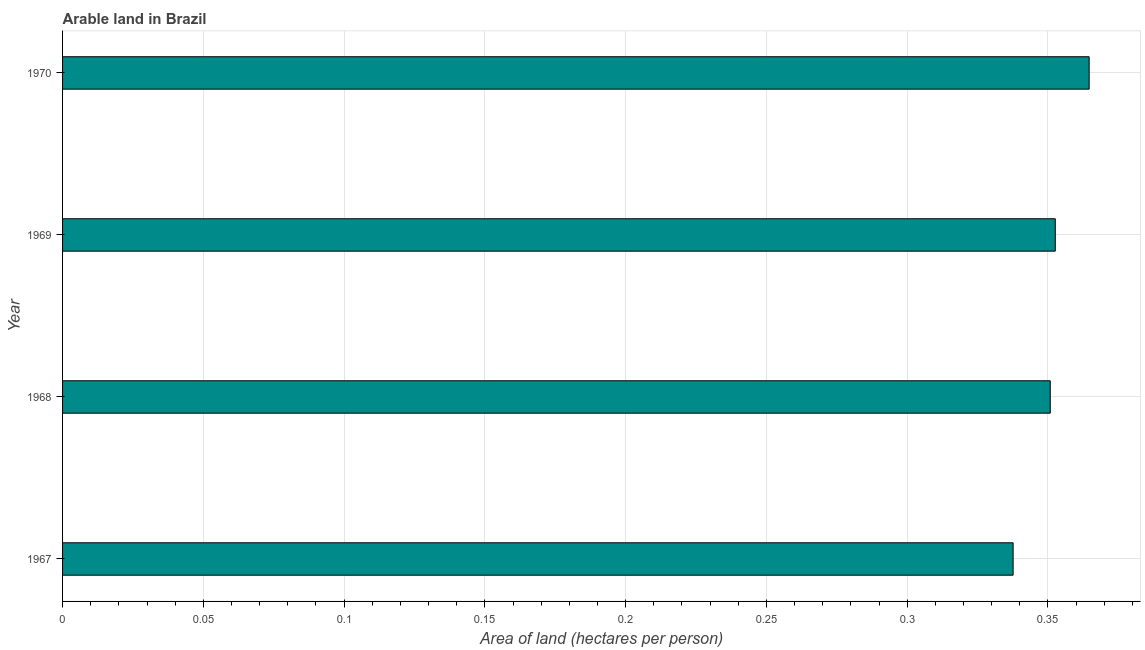Does the graph contain grids?
Your answer should be compact. Yes. What is the title of the graph?
Give a very brief answer. Arable land in Brazil. What is the label or title of the X-axis?
Your answer should be compact. Area of land (hectares per person). What is the label or title of the Y-axis?
Offer a terse response. Year. What is the area of arable land in 1970?
Provide a short and direct response. 0.36. Across all years, what is the maximum area of arable land?
Ensure brevity in your answer.  0.36. Across all years, what is the minimum area of arable land?
Make the answer very short. 0.34. In which year was the area of arable land maximum?
Your answer should be very brief. 1970. In which year was the area of arable land minimum?
Offer a terse response. 1967. What is the sum of the area of arable land?
Offer a very short reply. 1.41. What is the difference between the area of arable land in 1967 and 1968?
Give a very brief answer. -0.01. What is the average area of arable land per year?
Give a very brief answer. 0.35. What is the median area of arable land?
Offer a very short reply. 0.35. In how many years, is the area of arable land greater than 0.14 hectares per person?
Offer a very short reply. 4. What is the ratio of the area of arable land in 1967 to that in 1969?
Ensure brevity in your answer.  0.96. Is the difference between the area of arable land in 1967 and 1969 greater than the difference between any two years?
Ensure brevity in your answer.  No. What is the difference between the highest and the second highest area of arable land?
Provide a succinct answer. 0.01. Is the sum of the area of arable land in 1968 and 1969 greater than the maximum area of arable land across all years?
Provide a short and direct response. Yes. How many years are there in the graph?
Ensure brevity in your answer.  4. What is the difference between two consecutive major ticks on the X-axis?
Your answer should be compact. 0.05. What is the Area of land (hectares per person) of 1967?
Your answer should be compact. 0.34. What is the Area of land (hectares per person) in 1968?
Ensure brevity in your answer.  0.35. What is the Area of land (hectares per person) in 1969?
Your response must be concise. 0.35. What is the Area of land (hectares per person) of 1970?
Your response must be concise. 0.36. What is the difference between the Area of land (hectares per person) in 1967 and 1968?
Provide a succinct answer. -0.01. What is the difference between the Area of land (hectares per person) in 1967 and 1969?
Give a very brief answer. -0.01. What is the difference between the Area of land (hectares per person) in 1967 and 1970?
Your answer should be very brief. -0.03. What is the difference between the Area of land (hectares per person) in 1968 and 1969?
Offer a very short reply. -0. What is the difference between the Area of land (hectares per person) in 1968 and 1970?
Give a very brief answer. -0.01. What is the difference between the Area of land (hectares per person) in 1969 and 1970?
Make the answer very short. -0.01. What is the ratio of the Area of land (hectares per person) in 1967 to that in 1969?
Offer a very short reply. 0.96. What is the ratio of the Area of land (hectares per person) in 1967 to that in 1970?
Your response must be concise. 0.93. What is the ratio of the Area of land (hectares per person) in 1968 to that in 1969?
Give a very brief answer. 0.99. What is the ratio of the Area of land (hectares per person) in 1969 to that in 1970?
Give a very brief answer. 0.97. 